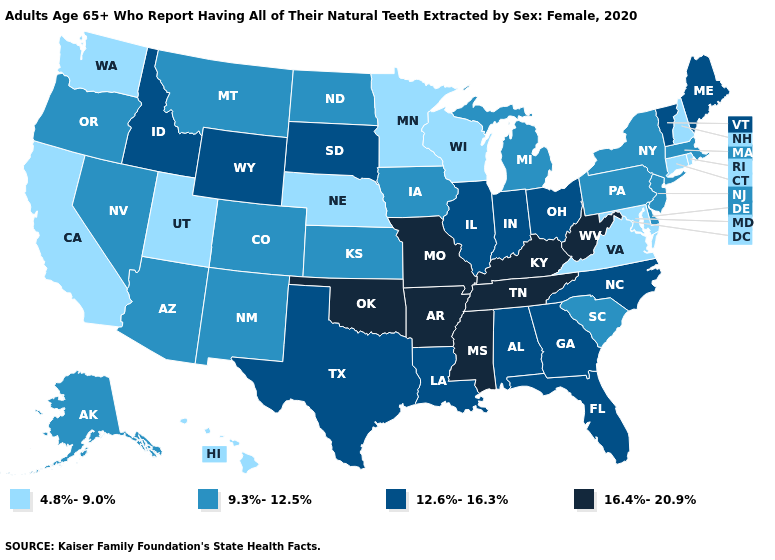Does Kansas have the lowest value in the USA?
Short answer required. No. Does Oklahoma have the same value as Arkansas?
Give a very brief answer. Yes. What is the lowest value in states that border New Hampshire?
Be succinct. 9.3%-12.5%. What is the lowest value in the Northeast?
Give a very brief answer. 4.8%-9.0%. Does California have the highest value in the USA?
Answer briefly. No. What is the value of Alabama?
Give a very brief answer. 12.6%-16.3%. Name the states that have a value in the range 16.4%-20.9%?
Give a very brief answer. Arkansas, Kentucky, Mississippi, Missouri, Oklahoma, Tennessee, West Virginia. Among the states that border Oklahoma , does New Mexico have the lowest value?
Be succinct. Yes. What is the value of Pennsylvania?
Write a very short answer. 9.3%-12.5%. Among the states that border Illinois , which have the lowest value?
Short answer required. Wisconsin. What is the value of New Mexico?
Concise answer only. 9.3%-12.5%. What is the value of South Dakota?
Write a very short answer. 12.6%-16.3%. Does Maine have the lowest value in the USA?
Concise answer only. No. Does Arkansas have the highest value in the USA?
Answer briefly. Yes. Does Wisconsin have the lowest value in the MidWest?
Short answer required. Yes. 